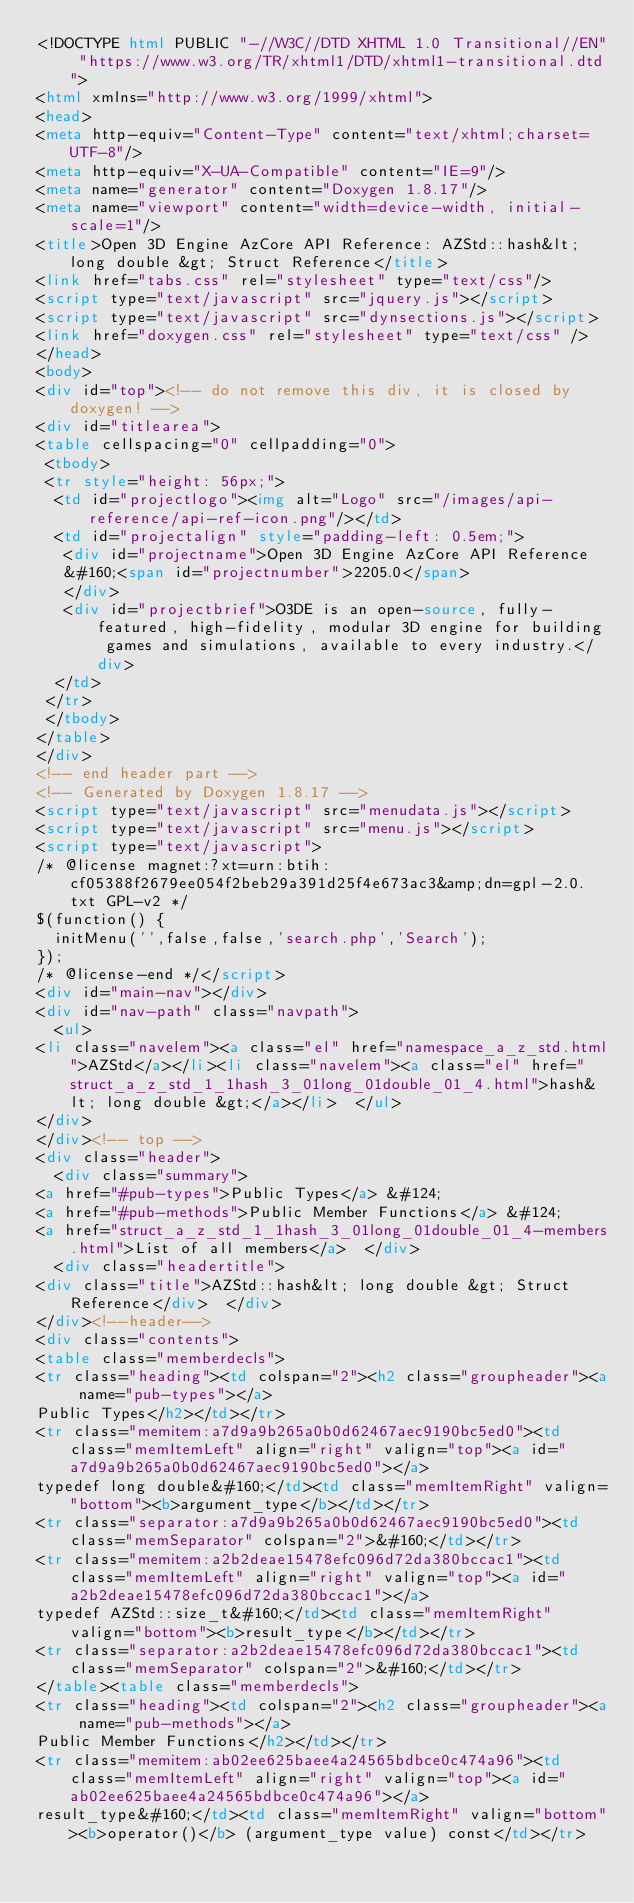<code> <loc_0><loc_0><loc_500><loc_500><_HTML_><!DOCTYPE html PUBLIC "-//W3C//DTD XHTML 1.0 Transitional//EN" "https://www.w3.org/TR/xhtml1/DTD/xhtml1-transitional.dtd">
<html xmlns="http://www.w3.org/1999/xhtml">
<head>
<meta http-equiv="Content-Type" content="text/xhtml;charset=UTF-8"/>
<meta http-equiv="X-UA-Compatible" content="IE=9"/>
<meta name="generator" content="Doxygen 1.8.17"/>
<meta name="viewport" content="width=device-width, initial-scale=1"/>
<title>Open 3D Engine AzCore API Reference: AZStd::hash&lt; long double &gt; Struct Reference</title>
<link href="tabs.css" rel="stylesheet" type="text/css"/>
<script type="text/javascript" src="jquery.js"></script>
<script type="text/javascript" src="dynsections.js"></script>
<link href="doxygen.css" rel="stylesheet" type="text/css" />
</head>
<body>
<div id="top"><!-- do not remove this div, it is closed by doxygen! -->
<div id="titlearea">
<table cellspacing="0" cellpadding="0">
 <tbody>
 <tr style="height: 56px;">
  <td id="projectlogo"><img alt="Logo" src="/images/api-reference/api-ref-icon.png"/></td>
  <td id="projectalign" style="padding-left: 0.5em;">
   <div id="projectname">Open 3D Engine AzCore API Reference
   &#160;<span id="projectnumber">2205.0</span>
   </div>
   <div id="projectbrief">O3DE is an open-source, fully-featured, high-fidelity, modular 3D engine for building games and simulations, available to every industry.</div>
  </td>
 </tr>
 </tbody>
</table>
</div>
<!-- end header part -->
<!-- Generated by Doxygen 1.8.17 -->
<script type="text/javascript" src="menudata.js"></script>
<script type="text/javascript" src="menu.js"></script>
<script type="text/javascript">
/* @license magnet:?xt=urn:btih:cf05388f2679ee054f2beb29a391d25f4e673ac3&amp;dn=gpl-2.0.txt GPL-v2 */
$(function() {
  initMenu('',false,false,'search.php','Search');
});
/* @license-end */</script>
<div id="main-nav"></div>
<div id="nav-path" class="navpath">
  <ul>
<li class="navelem"><a class="el" href="namespace_a_z_std.html">AZStd</a></li><li class="navelem"><a class="el" href="struct_a_z_std_1_1hash_3_01long_01double_01_4.html">hash&lt; long double &gt;</a></li>  </ul>
</div>
</div><!-- top -->
<div class="header">
  <div class="summary">
<a href="#pub-types">Public Types</a> &#124;
<a href="#pub-methods">Public Member Functions</a> &#124;
<a href="struct_a_z_std_1_1hash_3_01long_01double_01_4-members.html">List of all members</a>  </div>
  <div class="headertitle">
<div class="title">AZStd::hash&lt; long double &gt; Struct Reference</div>  </div>
</div><!--header-->
<div class="contents">
<table class="memberdecls">
<tr class="heading"><td colspan="2"><h2 class="groupheader"><a name="pub-types"></a>
Public Types</h2></td></tr>
<tr class="memitem:a7d9a9b265a0b0d62467aec9190bc5ed0"><td class="memItemLeft" align="right" valign="top"><a id="a7d9a9b265a0b0d62467aec9190bc5ed0"></a>
typedef long double&#160;</td><td class="memItemRight" valign="bottom"><b>argument_type</b></td></tr>
<tr class="separator:a7d9a9b265a0b0d62467aec9190bc5ed0"><td class="memSeparator" colspan="2">&#160;</td></tr>
<tr class="memitem:a2b2deae15478efc096d72da380bccac1"><td class="memItemLeft" align="right" valign="top"><a id="a2b2deae15478efc096d72da380bccac1"></a>
typedef AZStd::size_t&#160;</td><td class="memItemRight" valign="bottom"><b>result_type</b></td></tr>
<tr class="separator:a2b2deae15478efc096d72da380bccac1"><td class="memSeparator" colspan="2">&#160;</td></tr>
</table><table class="memberdecls">
<tr class="heading"><td colspan="2"><h2 class="groupheader"><a name="pub-methods"></a>
Public Member Functions</h2></td></tr>
<tr class="memitem:ab02ee625baee4a24565bdbce0c474a96"><td class="memItemLeft" align="right" valign="top"><a id="ab02ee625baee4a24565bdbce0c474a96"></a>
result_type&#160;</td><td class="memItemRight" valign="bottom"><b>operator()</b> (argument_type value) const</td></tr></code> 